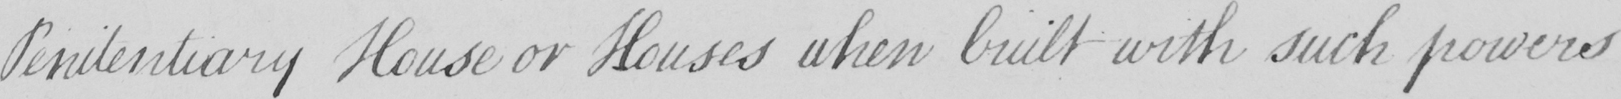Can you read and transcribe this handwriting? Penitentiary House or Houses when built with such powers 